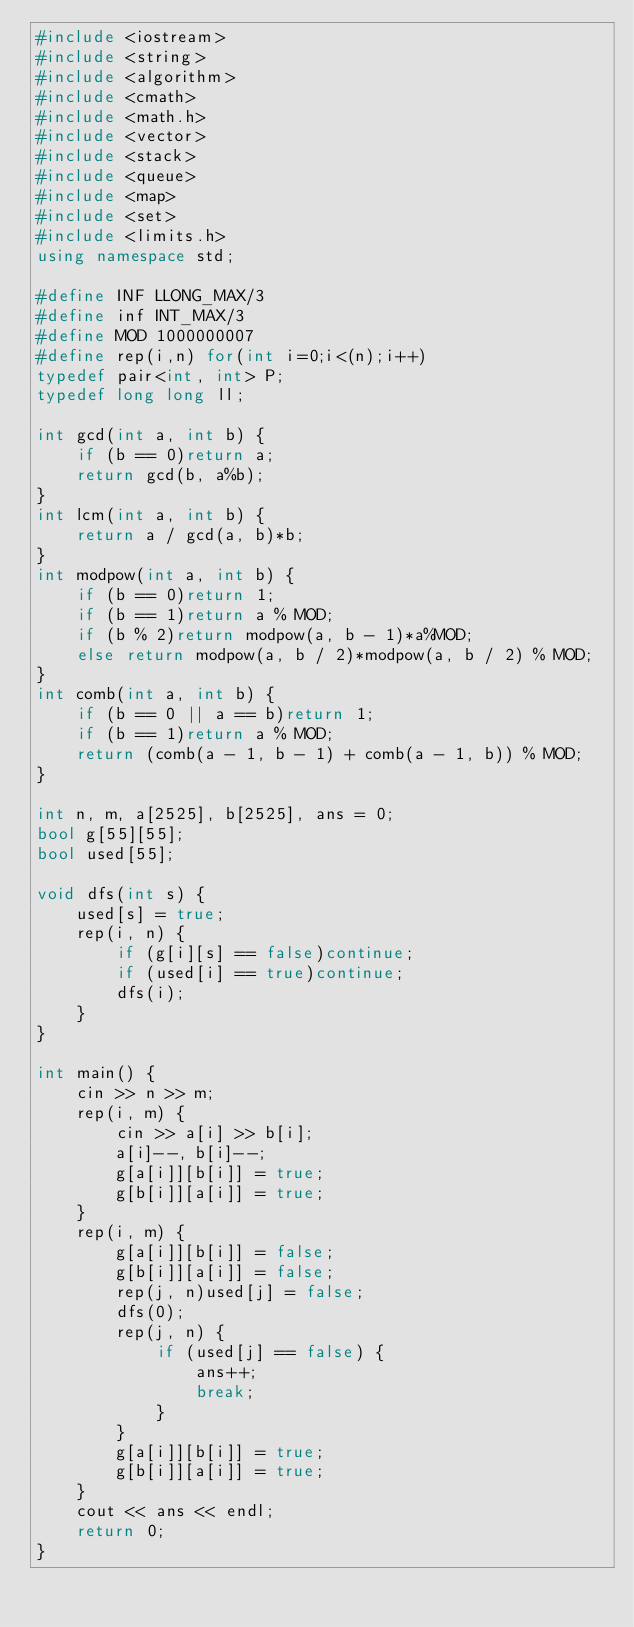<code> <loc_0><loc_0><loc_500><loc_500><_C++_>#include <iostream>
#include <string>
#include <algorithm>
#include <cmath>
#include <math.h>
#include <vector>
#include <stack>
#include <queue>
#include <map>
#include <set>
#include <limits.h>
using namespace std;

#define INF LLONG_MAX/3
#define inf INT_MAX/3
#define MOD 1000000007
#define rep(i,n) for(int i=0;i<(n);i++)
typedef pair<int, int> P;
typedef long long ll;

int gcd(int a, int b) {
	if (b == 0)return a;
	return gcd(b, a%b);
}
int lcm(int a, int b) {
	return a / gcd(a, b)*b;
}
int modpow(int a, int b) {
	if (b == 0)return 1;
	if (b == 1)return a % MOD;
	if (b % 2)return modpow(a, b - 1)*a%MOD;
	else return modpow(a, b / 2)*modpow(a, b / 2) % MOD;
}
int comb(int a, int b) {
	if (b == 0 || a == b)return 1;
	if (b == 1)return a % MOD;
	return (comb(a - 1, b - 1) + comb(a - 1, b)) % MOD;
}

int n, m, a[2525], b[2525], ans = 0;
bool g[55][55];
bool used[55];

void dfs(int s) {
	used[s] = true;
	rep(i, n) {
		if (g[i][s] == false)continue;
		if (used[i] == true)continue;
		dfs(i);
	}
}

int main() {
	cin >> n >> m;
	rep(i, m) {
		cin >> a[i] >> b[i];
		a[i]--, b[i]--;
		g[a[i]][b[i]] = true;
		g[b[i]][a[i]] = true;
	}
	rep(i, m) {
		g[a[i]][b[i]] = false;
		g[b[i]][a[i]] = false;
		rep(j, n)used[j] = false;
		dfs(0);
		rep(j, n) {
			if (used[j] == false) {
				ans++;
				break;
			}
		}
		g[a[i]][b[i]] = true;
		g[b[i]][a[i]] = true;
	}
	cout << ans << endl;
	return 0;
}</code> 